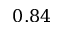Convert formula to latex. <formula><loc_0><loc_0><loc_500><loc_500>0 . 8 4</formula> 